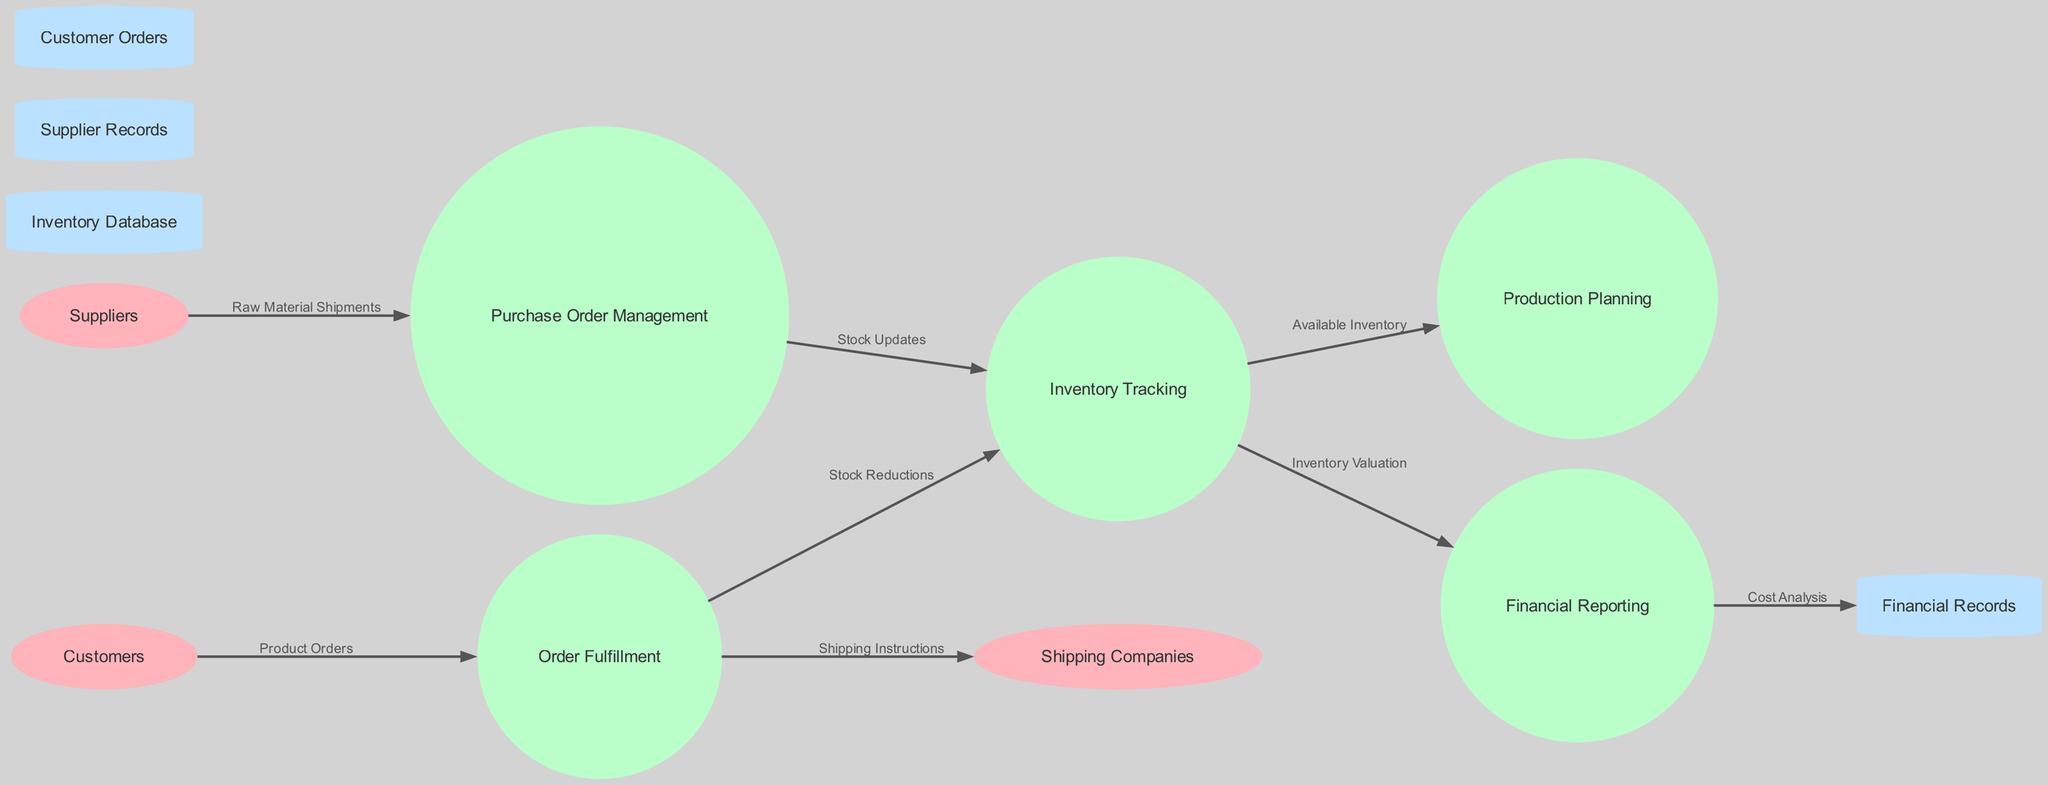What are the external entities in the diagram? The external entities are shown in ellipse shapes and include Suppliers, Customers, and Shipping Companies. These entities represent parties that interact with the processes of the system.
Answer: Suppliers, Customers, Shipping Companies How many processes are there in the diagram? By counting the circular nodes representing processes, we see there are five processes: Purchase Order Management, Inventory Tracking, Production Planning, Order Fulfillment, and Financial Reporting.
Answer: Five What does the ‘Stock Updates’ data flow connect? The data flow labeled 'Stock Updates' connects the Purchase Order Management process to the Inventory Tracking process, indicating that stock updates are made based on purchase orders.
Answer: Purchase Order Management and Inventory Tracking Which process receives 'Product Orders' from Customers? The flow labeled 'Product Orders' indicates that the Order Fulfillment process receives orders directly from Customers, reflecting the fulfillment of customer requests.
Answer: Order Fulfillment What is the next step after Inventory Tracking processes the 'Available Inventory'? The output from Inventory Tracking labeled 'Available Inventory' feeds into the Production Planning process. This shows that production decisions are based on what inventory is currently available.
Answer: Production Planning What does the ‘Cost Analysis’ flow provide to Financial Records? The data flow labeled 'Cost Analysis' provides insights from the Financial Reporting process to the Financial Records data store, ensuring that detailed costs associated with inventory and operations are documented.
Answer: Financial Records Which external entity is involved in shipping instructions? The external entity that receives shipping instructions from the Order Fulfillment process is Shipping Companies, indicating their role in executing the logistics of order delivery.
Answer: Shipping Companies What type of flow is 'Inventory Valuation'? The 'Inventory Valuation' flow comes from Inventory Tracking and connects to Financial Reporting, linking the physical inventory counts and costs to the financial aspects of the business.
Answer: Inventory Valuation How many data stores are there in the diagram? The data stores represented as cylindrical nodes include Inventory Database, Supplier Records, Customer Orders, and Financial Records. This totals four data stores in the diagram.
Answer: Four 